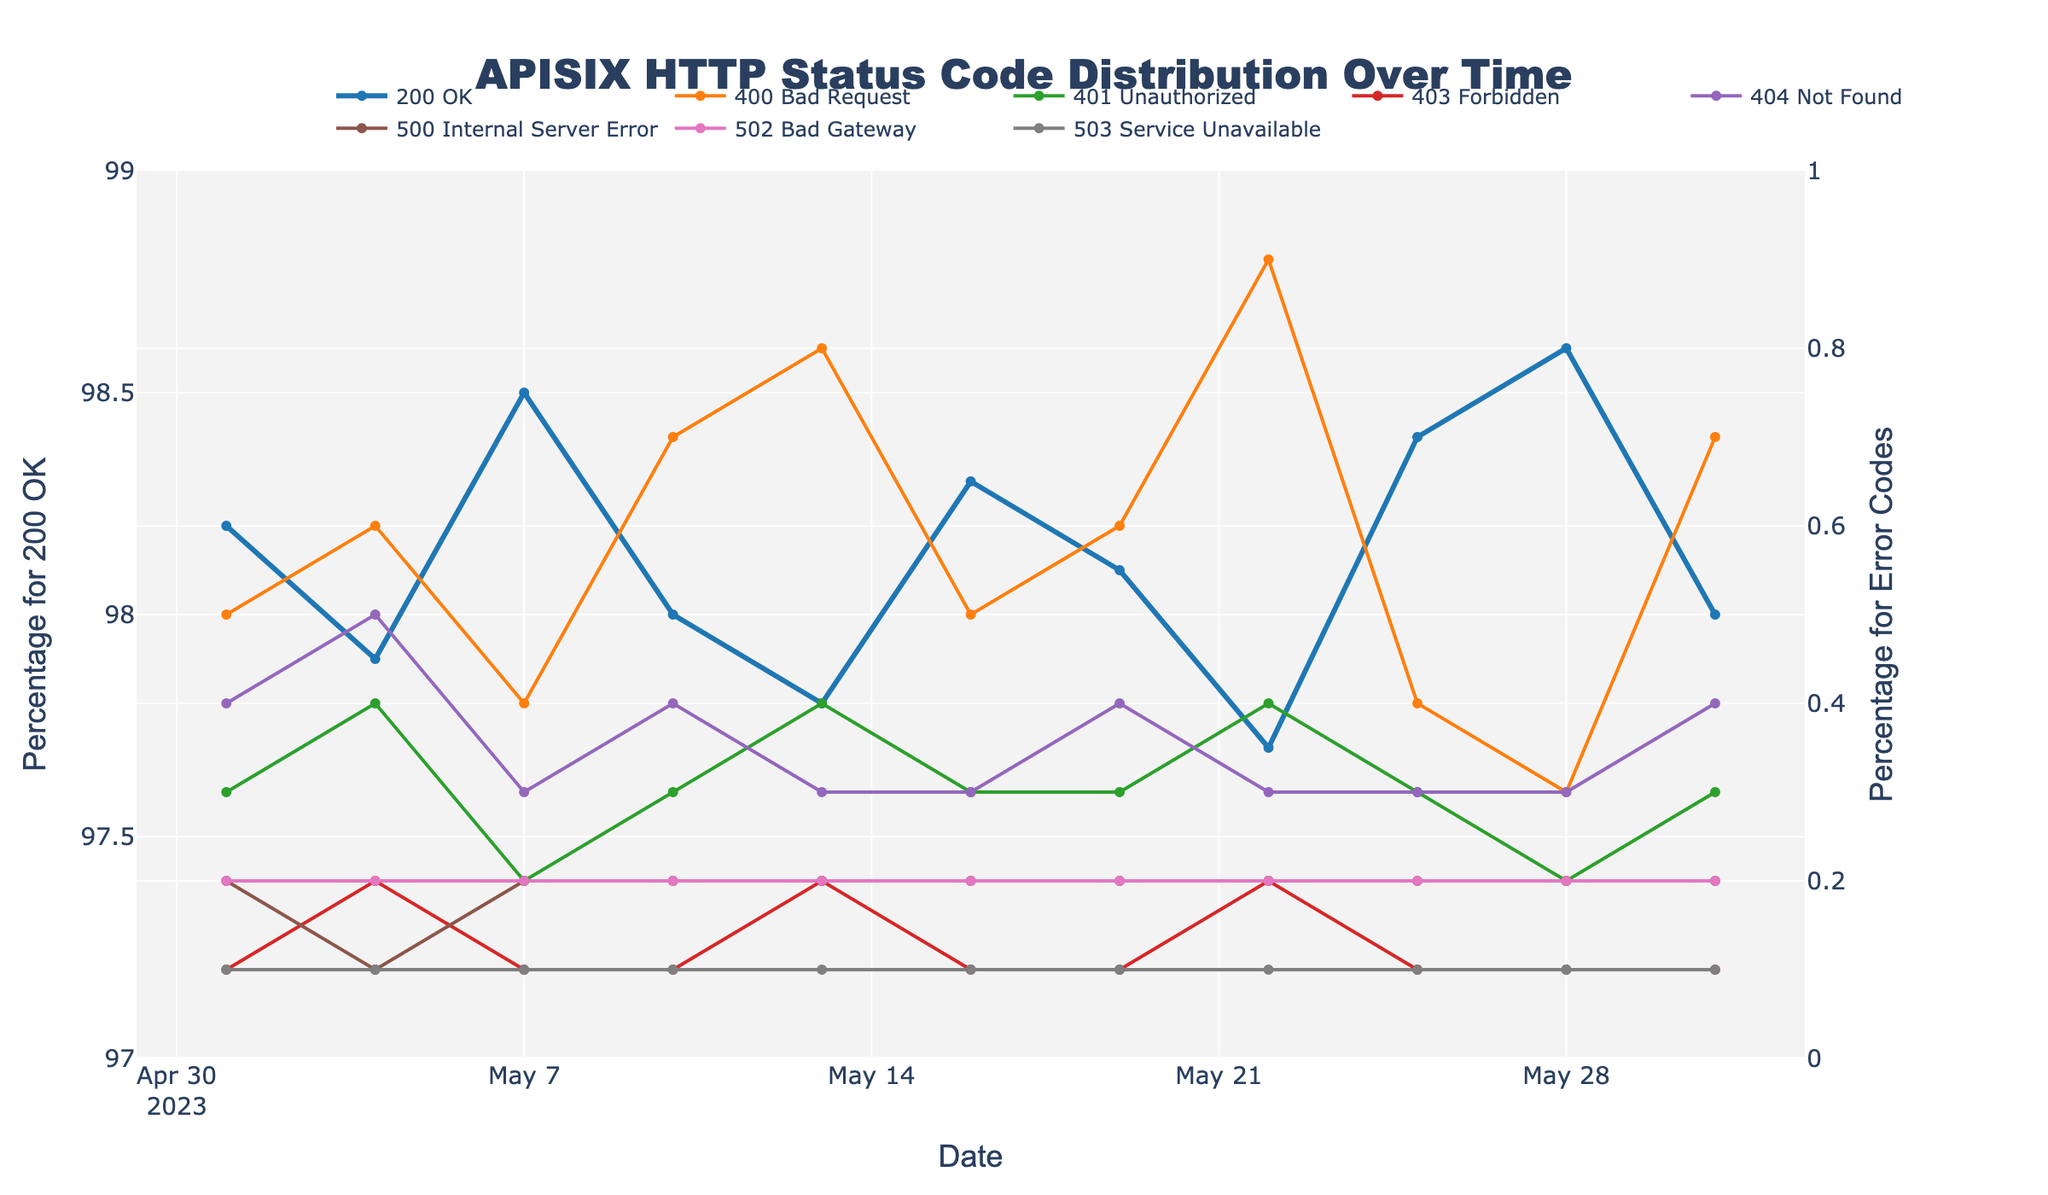what is the highest recorded percentage for 200 OK in the month? The chart shows the percentage of 200 OK responses for each recorded date. The highest value appears on 2023-05-28.
Answer: 98.6 which date recorded the highest percentage of 400 Bad Request errors? Observing the trend line for the 400 Bad Request in the plot, the peak occurrence is on 2023-05-22.
Answer: 0.9 how does the percentage of errors on 2023-05-10 compare to 2023-05-25 for 401 Unauthorized and 403 Forbidden? For 401 Unauthorized, the percentage on 2023-05-10 is 0.3, on 2023-05-25 is also 0.3. For 403 Forbidden, it is 0.1 on both dates. Both sets of error rates have remained the same on these dates.
Answer: equal what is the difference in the percentage of 200 OK between the highest and the lowest recorded values? The highest percentage for 200 OK is 98.6 (on 2023-05-28) and the lowest is 97.7 (on 2023-05-22). The difference is 98.6 - 97.7 = 0.9.
Answer: 0.9 which error code appeared consistently at 0.1% over the whole month? Inspecting the trend for all error codes, 503 Service Unavailable appears to consistently stay at 0.1% for all the dates.
Answer: 503 Service Unavailable on which date did the total percentage for errors (non-200 status codes) peak in the given month? Adding up the percentages for all error codes: on 2023-05-22 is 0.9 + 0.4 + 0.2 + 0.3 + 0.2 + 0.2 = 2.2. Comparing other dates, 2023-05-22 is the highest.
Answer: 2023-05-22 how does the trend for 404 Not Found change over the month? Observing the trend line for 404 Not Found, it remains relatively constant between 0.3% to 0.5%, with some minor fluctuations throughout the month.
Answer: fluctuates between 0.3% and 0.5% is the percentage of 500 Internal Server Error higher or lower than the percentage of 502 Bad Gateway for the majority of the month? Comparing the two lines for most of the dates, the percentage values for 500 Internal Server Error and 502 Bad Gateway are equal at 0.2% for every date.
Answer: equal how many dates recorded a percentage for 400 Bad Request that was greater than or equal to 0.8%? By examining the trend for 400 Bad Request, the dates 2023-05-22 and 2023-05-13 show the percentage >= 0.8% which adds up to two dates.
Answer: 2 